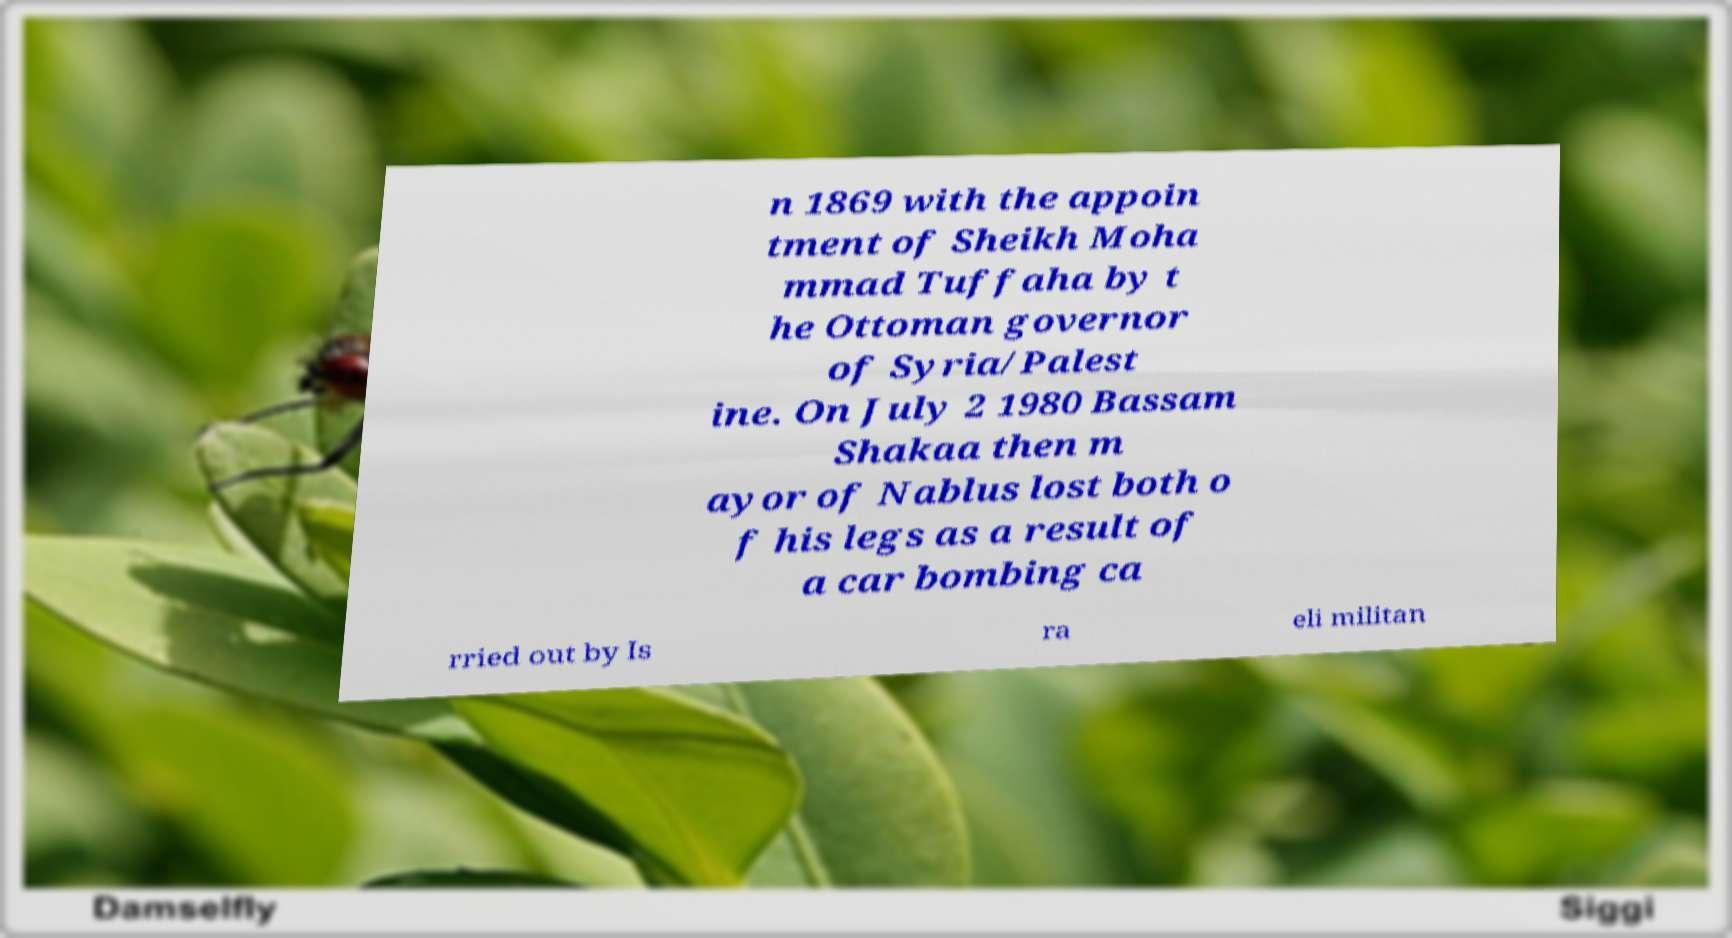Please identify and transcribe the text found in this image. n 1869 with the appoin tment of Sheikh Moha mmad Tuffaha by t he Ottoman governor of Syria/Palest ine. On July 2 1980 Bassam Shakaa then m ayor of Nablus lost both o f his legs as a result of a car bombing ca rried out by Is ra eli militan 